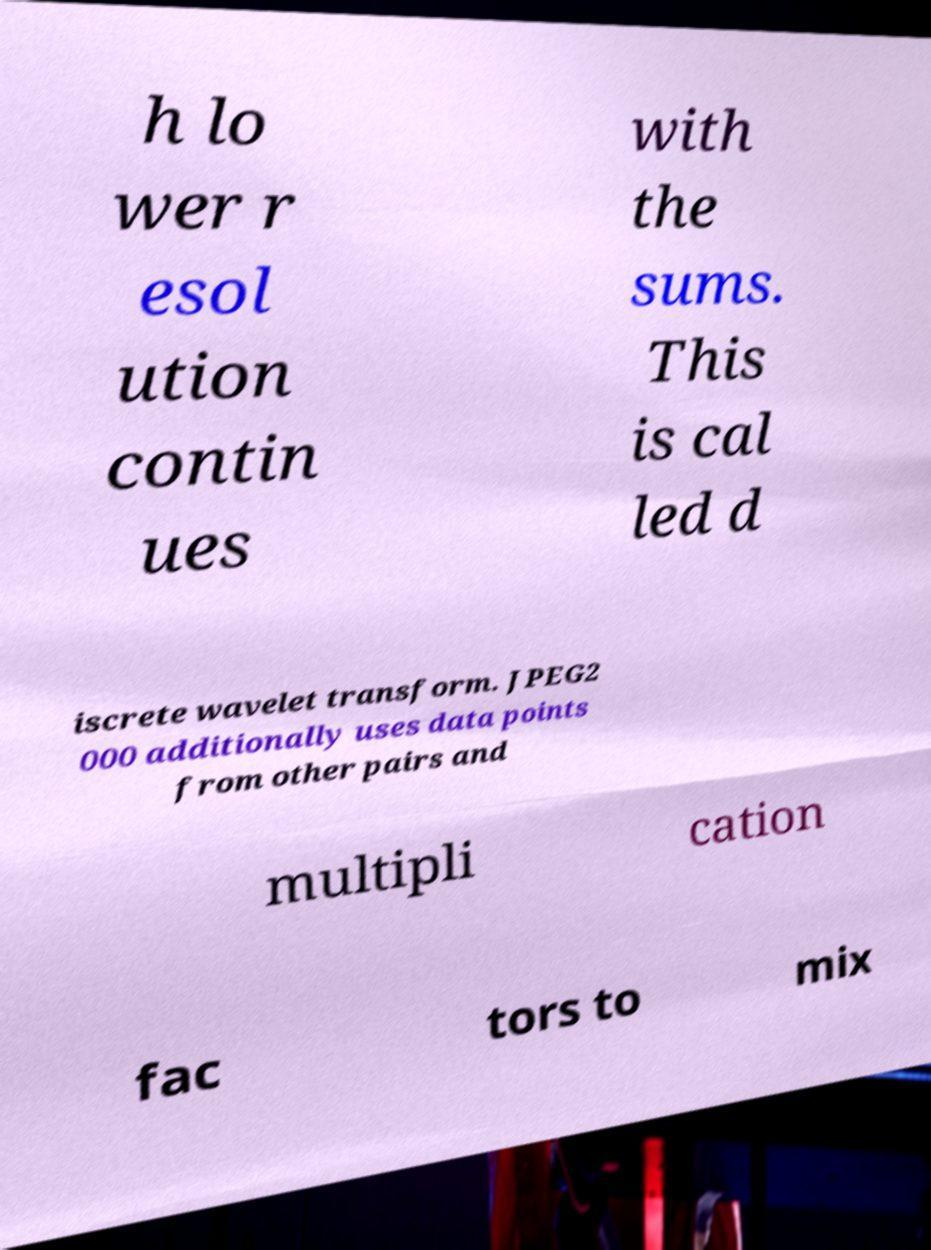Can you read and provide the text displayed in the image?This photo seems to have some interesting text. Can you extract and type it out for me? h lo wer r esol ution contin ues with the sums. This is cal led d iscrete wavelet transform. JPEG2 000 additionally uses data points from other pairs and multipli cation fac tors to mix 